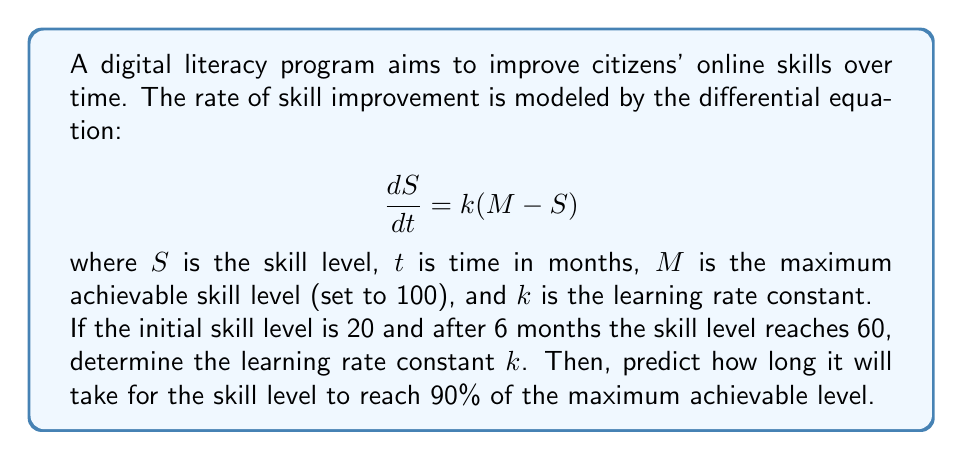Show me your answer to this math problem. To solve this problem, we'll follow these steps:

1) First, we need to solve the given differential equation:
   $$\frac{dS}{dt} = k(M - S)$$

   This is a separable equation. Rearranging and integrating both sides:
   $$\int \frac{dS}{M-S} = \int k dt$$
   $$-\ln(M-S) = kt + C$$

   Solving for $S$:
   $$S = M - Ae^{-kt}$$
   where $A$ is a constant of integration.

2) We can find $A$ using the initial condition $S(0) = 20$:
   $$20 = 100 - A$$
   $$A = 80$$

   So our solution is:
   $$S = 100 - 80e^{-kt}$$

3) Now we can use the condition that $S(6) = 60$ to find $k$:
   $$60 = 100 - 80e^{-6k}$$
   $$40 = 80e^{-6k}$$
   $$0.5 = e^{-6k}$$
   $$\ln(0.5) = -6k$$
   $$k = \frac{\ln(2)}{6} \approx 0.1155$$

4) To find when the skill level reaches 90% of the maximum (90), we solve:
   $$90 = 100 - 80e^{-kt}$$
   $$10 = 80e^{-kt}$$
   $$\frac{1}{8} = e^{-kt}$$
   $$\ln(\frac{1}{8}) = -kt$$
   $$t = \frac{\ln(8)}{k} \approx 18.07$$

Therefore, it will take approximately 18.07 months to reach 90% of the maximum skill level.
Answer: The learning rate constant $k$ is approximately 0.1155 per month. It will take approximately 18.07 months for the skill level to reach 90% of the maximum achievable level. 